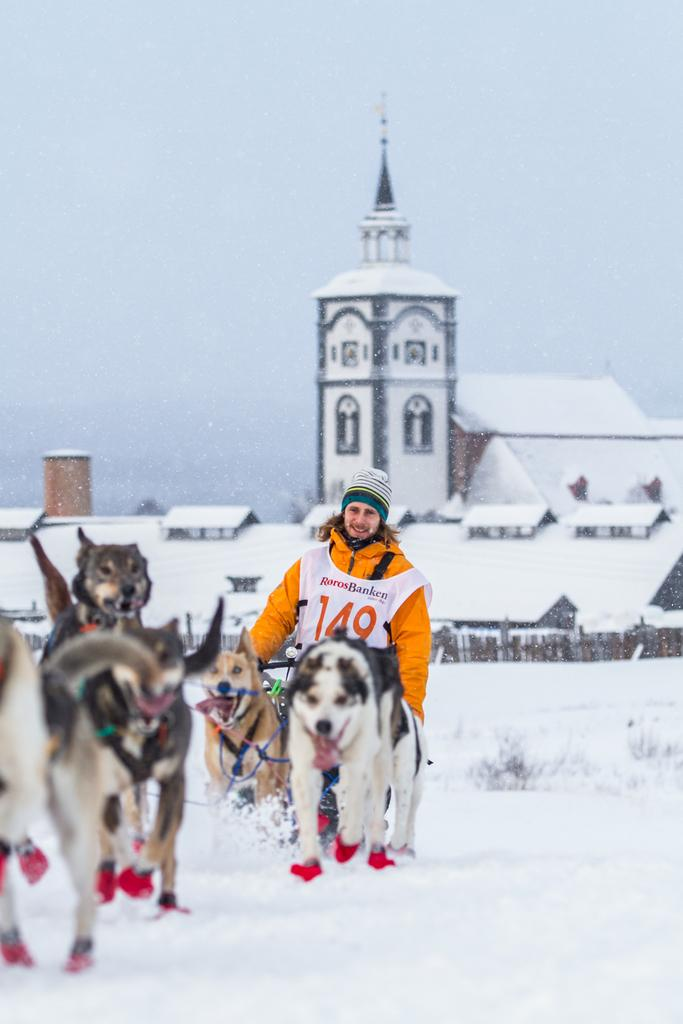What is the condition of the land in the image? The land is covered with snow. Can you describe the people and animals in the image? There is a person and dogs in the image. What is visible in the distance? There is a building in the distance, covered with snow. What time of day is it in the image, based on the society's hour system? The provided facts do not mention any time of day or hour system, so it cannot be determined from the image. 